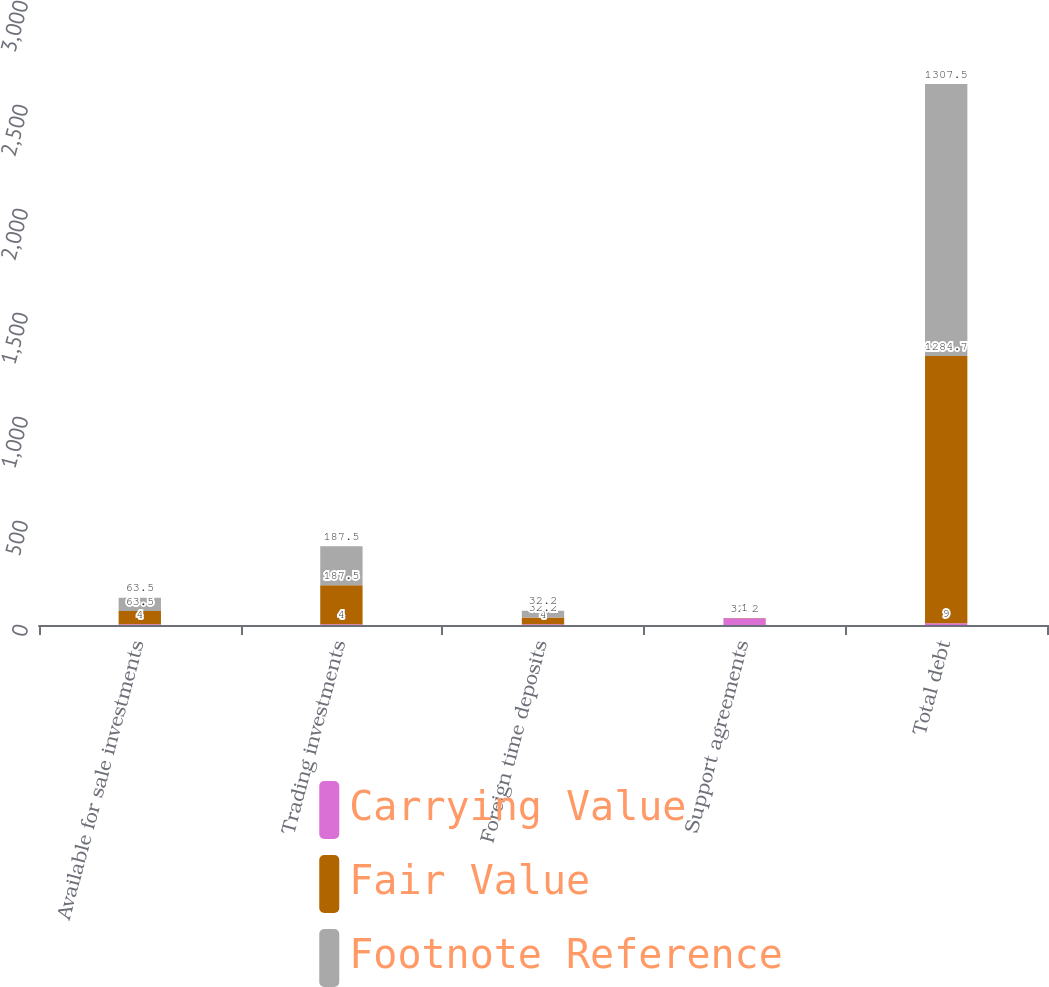Convert chart to OTSL. <chart><loc_0><loc_0><loc_500><loc_500><stacked_bar_chart><ecel><fcel>Available for sale investments<fcel>Trading investments<fcel>Foreign time deposits<fcel>Support agreements<fcel>Total debt<nl><fcel>Carrying Value<fcel>4<fcel>4<fcel>4<fcel>32.2<fcel>9<nl><fcel>Fair Value<fcel>63.5<fcel>187.5<fcel>32.2<fcel>1<fcel>1284.7<nl><fcel>Footnote Reference<fcel>63.5<fcel>187.5<fcel>32.2<fcel>1<fcel>1307.5<nl></chart> 